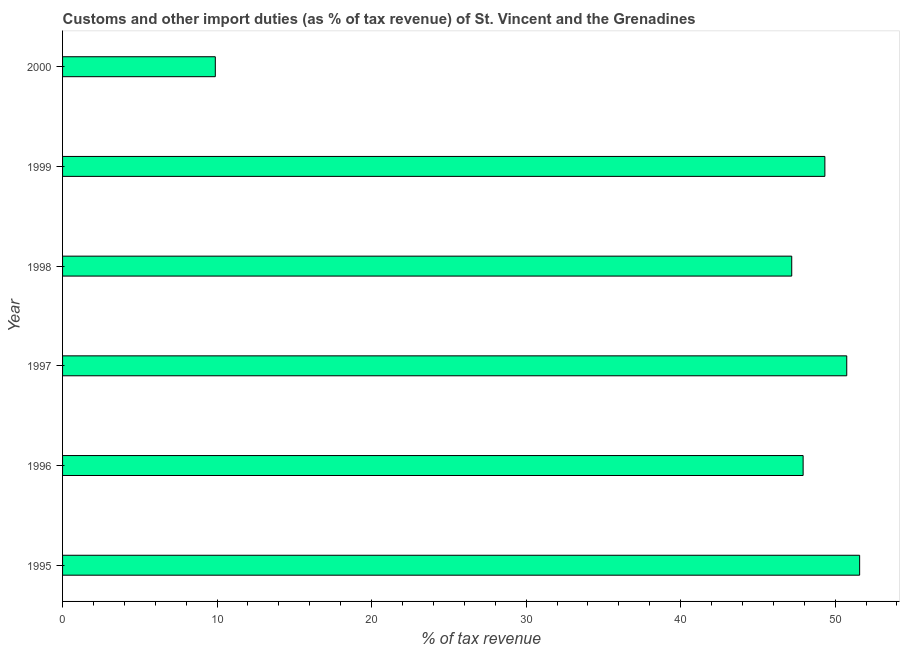Does the graph contain any zero values?
Provide a short and direct response. No. Does the graph contain grids?
Keep it short and to the point. No. What is the title of the graph?
Your answer should be compact. Customs and other import duties (as % of tax revenue) of St. Vincent and the Grenadines. What is the label or title of the X-axis?
Make the answer very short. % of tax revenue. What is the label or title of the Y-axis?
Provide a short and direct response. Year. What is the customs and other import duties in 1997?
Give a very brief answer. 50.75. Across all years, what is the maximum customs and other import duties?
Keep it short and to the point. 51.59. Across all years, what is the minimum customs and other import duties?
Offer a terse response. 9.89. What is the sum of the customs and other import duties?
Provide a short and direct response. 256.68. What is the difference between the customs and other import duties in 1995 and 1996?
Offer a terse response. 3.66. What is the average customs and other import duties per year?
Make the answer very short. 42.78. What is the median customs and other import duties?
Provide a short and direct response. 48.63. Do a majority of the years between 1998 and 1995 (inclusive) have customs and other import duties greater than 38 %?
Your answer should be very brief. Yes. What is the ratio of the customs and other import duties in 1995 to that in 2000?
Offer a very short reply. 5.22. Is the difference between the customs and other import duties in 1995 and 1996 greater than the difference between any two years?
Your answer should be very brief. No. What is the difference between the highest and the second highest customs and other import duties?
Keep it short and to the point. 0.83. Is the sum of the customs and other import duties in 1996 and 2000 greater than the maximum customs and other import duties across all years?
Keep it short and to the point. Yes. What is the difference between the highest and the lowest customs and other import duties?
Offer a terse response. 41.7. In how many years, is the customs and other import duties greater than the average customs and other import duties taken over all years?
Your response must be concise. 5. How many bars are there?
Offer a very short reply. 6. How many years are there in the graph?
Your answer should be very brief. 6. What is the % of tax revenue of 1995?
Give a very brief answer. 51.59. What is the % of tax revenue in 1996?
Offer a very short reply. 47.93. What is the % of tax revenue of 1997?
Provide a short and direct response. 50.75. What is the % of tax revenue of 1998?
Give a very brief answer. 47.19. What is the % of tax revenue of 1999?
Provide a succinct answer. 49.34. What is the % of tax revenue of 2000?
Your answer should be very brief. 9.89. What is the difference between the % of tax revenue in 1995 and 1996?
Your answer should be compact. 3.66. What is the difference between the % of tax revenue in 1995 and 1997?
Provide a succinct answer. 0.83. What is the difference between the % of tax revenue in 1995 and 1998?
Your answer should be very brief. 4.39. What is the difference between the % of tax revenue in 1995 and 1999?
Provide a succinct answer. 2.25. What is the difference between the % of tax revenue in 1995 and 2000?
Offer a very short reply. 41.7. What is the difference between the % of tax revenue in 1996 and 1997?
Your response must be concise. -2.82. What is the difference between the % of tax revenue in 1996 and 1998?
Your answer should be compact. 0.74. What is the difference between the % of tax revenue in 1996 and 1999?
Provide a short and direct response. -1.41. What is the difference between the % of tax revenue in 1996 and 2000?
Offer a very short reply. 38.04. What is the difference between the % of tax revenue in 1997 and 1998?
Your answer should be compact. 3.56. What is the difference between the % of tax revenue in 1997 and 1999?
Ensure brevity in your answer.  1.42. What is the difference between the % of tax revenue in 1997 and 2000?
Ensure brevity in your answer.  40.87. What is the difference between the % of tax revenue in 1998 and 1999?
Give a very brief answer. -2.14. What is the difference between the % of tax revenue in 1998 and 2000?
Provide a succinct answer. 37.31. What is the difference between the % of tax revenue in 1999 and 2000?
Your answer should be very brief. 39.45. What is the ratio of the % of tax revenue in 1995 to that in 1996?
Provide a succinct answer. 1.08. What is the ratio of the % of tax revenue in 1995 to that in 1997?
Make the answer very short. 1.02. What is the ratio of the % of tax revenue in 1995 to that in 1998?
Your response must be concise. 1.09. What is the ratio of the % of tax revenue in 1995 to that in 1999?
Offer a terse response. 1.05. What is the ratio of the % of tax revenue in 1995 to that in 2000?
Offer a terse response. 5.22. What is the ratio of the % of tax revenue in 1996 to that in 1997?
Your response must be concise. 0.94. What is the ratio of the % of tax revenue in 1996 to that in 1999?
Provide a succinct answer. 0.97. What is the ratio of the % of tax revenue in 1996 to that in 2000?
Your response must be concise. 4.85. What is the ratio of the % of tax revenue in 1997 to that in 1998?
Offer a terse response. 1.07. What is the ratio of the % of tax revenue in 1997 to that in 1999?
Provide a succinct answer. 1.03. What is the ratio of the % of tax revenue in 1997 to that in 2000?
Offer a terse response. 5.13. What is the ratio of the % of tax revenue in 1998 to that in 2000?
Your answer should be very brief. 4.77. What is the ratio of the % of tax revenue in 1999 to that in 2000?
Your response must be concise. 4.99. 